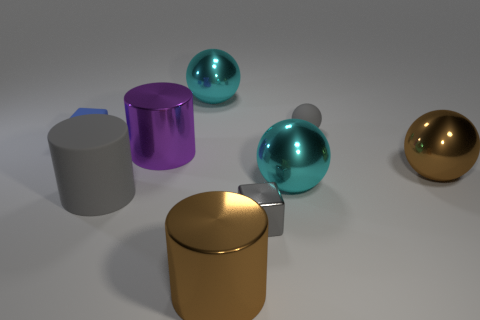Subtract 1 spheres. How many spheres are left? 3 Subtract all blocks. How many objects are left? 7 Add 4 small gray blocks. How many small gray blocks exist? 5 Subtract 1 gray balls. How many objects are left? 8 Subtract all metal blocks. Subtract all large cylinders. How many objects are left? 5 Add 4 big purple objects. How many big purple objects are left? 5 